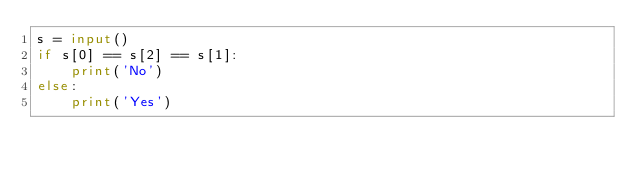<code> <loc_0><loc_0><loc_500><loc_500><_Python_>s = input()
if s[0] == s[2] == s[1]:
    print('No')
else:
    print('Yes')</code> 